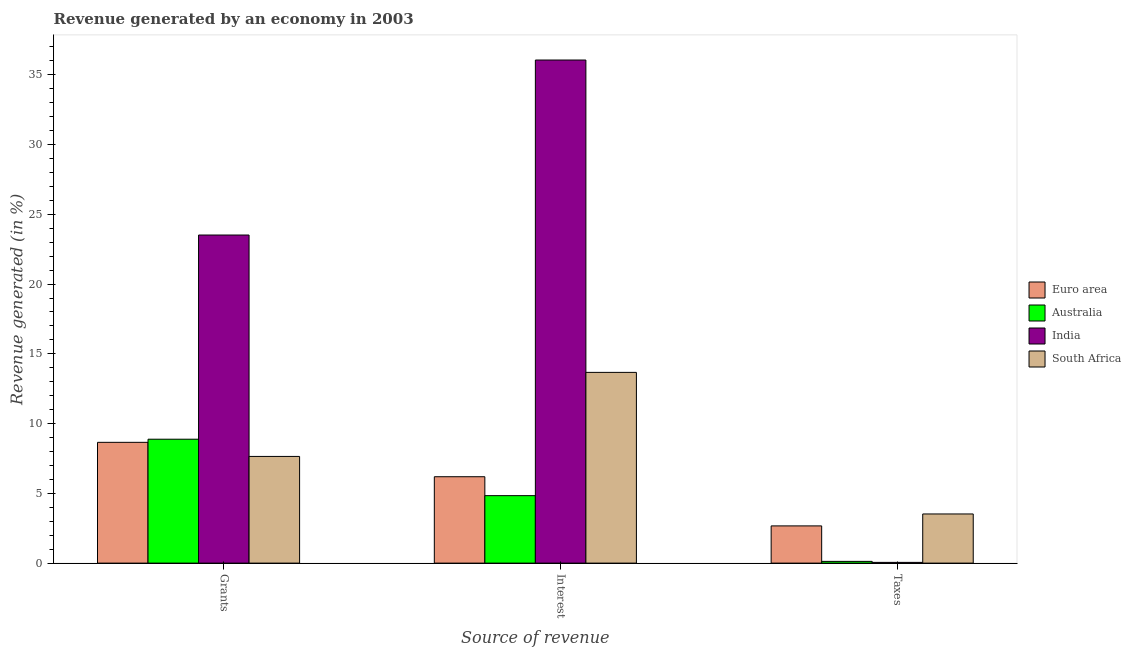How many bars are there on the 1st tick from the left?
Your response must be concise. 4. How many bars are there on the 2nd tick from the right?
Offer a very short reply. 4. What is the label of the 1st group of bars from the left?
Ensure brevity in your answer.  Grants. What is the percentage of revenue generated by grants in Australia?
Provide a short and direct response. 8.88. Across all countries, what is the maximum percentage of revenue generated by grants?
Offer a very short reply. 23.52. Across all countries, what is the minimum percentage of revenue generated by grants?
Give a very brief answer. 7.65. In which country was the percentage of revenue generated by taxes maximum?
Give a very brief answer. South Africa. What is the total percentage of revenue generated by interest in the graph?
Offer a very short reply. 60.76. What is the difference between the percentage of revenue generated by grants in India and that in South Africa?
Give a very brief answer. 15.87. What is the difference between the percentage of revenue generated by grants in Euro area and the percentage of revenue generated by taxes in South Africa?
Offer a very short reply. 5.13. What is the average percentage of revenue generated by interest per country?
Offer a terse response. 15.19. What is the difference between the percentage of revenue generated by grants and percentage of revenue generated by taxes in India?
Keep it short and to the point. 23.46. What is the ratio of the percentage of revenue generated by grants in Australia to that in Euro area?
Offer a very short reply. 1.03. Is the percentage of revenue generated by interest in Euro area less than that in Australia?
Your answer should be compact. No. Is the difference between the percentage of revenue generated by interest in Euro area and India greater than the difference between the percentage of revenue generated by grants in Euro area and India?
Give a very brief answer. No. What is the difference between the highest and the second highest percentage of revenue generated by grants?
Offer a terse response. 14.63. What is the difference between the highest and the lowest percentage of revenue generated by grants?
Your response must be concise. 15.87. In how many countries, is the percentage of revenue generated by grants greater than the average percentage of revenue generated by grants taken over all countries?
Give a very brief answer. 1. Is the sum of the percentage of revenue generated by taxes in South Africa and Euro area greater than the maximum percentage of revenue generated by interest across all countries?
Your response must be concise. No. What does the 4th bar from the left in Taxes represents?
Your answer should be compact. South Africa. What does the 1st bar from the right in Interest represents?
Offer a terse response. South Africa. Is it the case that in every country, the sum of the percentage of revenue generated by grants and percentage of revenue generated by interest is greater than the percentage of revenue generated by taxes?
Offer a terse response. Yes. Does the graph contain grids?
Your answer should be compact. No. Where does the legend appear in the graph?
Give a very brief answer. Center right. How many legend labels are there?
Offer a terse response. 4. How are the legend labels stacked?
Provide a short and direct response. Vertical. What is the title of the graph?
Give a very brief answer. Revenue generated by an economy in 2003. Does "Uruguay" appear as one of the legend labels in the graph?
Keep it short and to the point. No. What is the label or title of the X-axis?
Offer a very short reply. Source of revenue. What is the label or title of the Y-axis?
Provide a succinct answer. Revenue generated (in %). What is the Revenue generated (in %) in Euro area in Grants?
Your response must be concise. 8.66. What is the Revenue generated (in %) of Australia in Grants?
Give a very brief answer. 8.88. What is the Revenue generated (in %) in India in Grants?
Provide a succinct answer. 23.52. What is the Revenue generated (in %) of South Africa in Grants?
Your response must be concise. 7.65. What is the Revenue generated (in %) in Euro area in Interest?
Keep it short and to the point. 6.19. What is the Revenue generated (in %) of Australia in Interest?
Provide a short and direct response. 4.84. What is the Revenue generated (in %) of India in Interest?
Ensure brevity in your answer.  36.06. What is the Revenue generated (in %) of South Africa in Interest?
Keep it short and to the point. 13.67. What is the Revenue generated (in %) in Euro area in Taxes?
Make the answer very short. 2.67. What is the Revenue generated (in %) of Australia in Taxes?
Give a very brief answer. 0.12. What is the Revenue generated (in %) in India in Taxes?
Offer a very short reply. 0.05. What is the Revenue generated (in %) in South Africa in Taxes?
Offer a very short reply. 3.52. Across all Source of revenue, what is the maximum Revenue generated (in %) in Euro area?
Your answer should be compact. 8.66. Across all Source of revenue, what is the maximum Revenue generated (in %) of Australia?
Provide a short and direct response. 8.88. Across all Source of revenue, what is the maximum Revenue generated (in %) of India?
Your response must be concise. 36.06. Across all Source of revenue, what is the maximum Revenue generated (in %) in South Africa?
Give a very brief answer. 13.67. Across all Source of revenue, what is the minimum Revenue generated (in %) in Euro area?
Provide a succinct answer. 2.67. Across all Source of revenue, what is the minimum Revenue generated (in %) of Australia?
Your answer should be compact. 0.12. Across all Source of revenue, what is the minimum Revenue generated (in %) of India?
Offer a very short reply. 0.05. Across all Source of revenue, what is the minimum Revenue generated (in %) of South Africa?
Ensure brevity in your answer.  3.52. What is the total Revenue generated (in %) of Euro area in the graph?
Offer a terse response. 17.52. What is the total Revenue generated (in %) in Australia in the graph?
Make the answer very short. 13.84. What is the total Revenue generated (in %) in India in the graph?
Provide a succinct answer. 59.63. What is the total Revenue generated (in %) of South Africa in the graph?
Offer a terse response. 24.84. What is the difference between the Revenue generated (in %) in Euro area in Grants and that in Interest?
Give a very brief answer. 2.46. What is the difference between the Revenue generated (in %) of Australia in Grants and that in Interest?
Provide a succinct answer. 4.05. What is the difference between the Revenue generated (in %) of India in Grants and that in Interest?
Provide a short and direct response. -12.54. What is the difference between the Revenue generated (in %) of South Africa in Grants and that in Interest?
Provide a short and direct response. -6.03. What is the difference between the Revenue generated (in %) in Euro area in Grants and that in Taxes?
Ensure brevity in your answer.  5.99. What is the difference between the Revenue generated (in %) of Australia in Grants and that in Taxes?
Give a very brief answer. 8.76. What is the difference between the Revenue generated (in %) in India in Grants and that in Taxes?
Offer a very short reply. 23.46. What is the difference between the Revenue generated (in %) in South Africa in Grants and that in Taxes?
Keep it short and to the point. 4.12. What is the difference between the Revenue generated (in %) of Euro area in Interest and that in Taxes?
Give a very brief answer. 3.52. What is the difference between the Revenue generated (in %) of Australia in Interest and that in Taxes?
Provide a short and direct response. 4.71. What is the difference between the Revenue generated (in %) of India in Interest and that in Taxes?
Provide a succinct answer. 36.01. What is the difference between the Revenue generated (in %) of South Africa in Interest and that in Taxes?
Provide a succinct answer. 10.15. What is the difference between the Revenue generated (in %) of Euro area in Grants and the Revenue generated (in %) of Australia in Interest?
Your response must be concise. 3.82. What is the difference between the Revenue generated (in %) of Euro area in Grants and the Revenue generated (in %) of India in Interest?
Make the answer very short. -27.4. What is the difference between the Revenue generated (in %) in Euro area in Grants and the Revenue generated (in %) in South Africa in Interest?
Give a very brief answer. -5.01. What is the difference between the Revenue generated (in %) of Australia in Grants and the Revenue generated (in %) of India in Interest?
Provide a succinct answer. -27.18. What is the difference between the Revenue generated (in %) of Australia in Grants and the Revenue generated (in %) of South Africa in Interest?
Provide a short and direct response. -4.79. What is the difference between the Revenue generated (in %) of India in Grants and the Revenue generated (in %) of South Africa in Interest?
Provide a short and direct response. 9.84. What is the difference between the Revenue generated (in %) in Euro area in Grants and the Revenue generated (in %) in Australia in Taxes?
Your response must be concise. 8.53. What is the difference between the Revenue generated (in %) of Euro area in Grants and the Revenue generated (in %) of India in Taxes?
Your answer should be very brief. 8.6. What is the difference between the Revenue generated (in %) of Euro area in Grants and the Revenue generated (in %) of South Africa in Taxes?
Your response must be concise. 5.13. What is the difference between the Revenue generated (in %) of Australia in Grants and the Revenue generated (in %) of India in Taxes?
Offer a very short reply. 8.83. What is the difference between the Revenue generated (in %) in Australia in Grants and the Revenue generated (in %) in South Africa in Taxes?
Your answer should be very brief. 5.36. What is the difference between the Revenue generated (in %) in India in Grants and the Revenue generated (in %) in South Africa in Taxes?
Your answer should be very brief. 19.99. What is the difference between the Revenue generated (in %) in Euro area in Interest and the Revenue generated (in %) in Australia in Taxes?
Make the answer very short. 6.07. What is the difference between the Revenue generated (in %) in Euro area in Interest and the Revenue generated (in %) in India in Taxes?
Give a very brief answer. 6.14. What is the difference between the Revenue generated (in %) in Euro area in Interest and the Revenue generated (in %) in South Africa in Taxes?
Your answer should be compact. 2.67. What is the difference between the Revenue generated (in %) of Australia in Interest and the Revenue generated (in %) of India in Taxes?
Ensure brevity in your answer.  4.78. What is the difference between the Revenue generated (in %) in Australia in Interest and the Revenue generated (in %) in South Africa in Taxes?
Keep it short and to the point. 1.31. What is the difference between the Revenue generated (in %) of India in Interest and the Revenue generated (in %) of South Africa in Taxes?
Offer a very short reply. 32.54. What is the average Revenue generated (in %) in Euro area per Source of revenue?
Provide a short and direct response. 5.84. What is the average Revenue generated (in %) in Australia per Source of revenue?
Provide a succinct answer. 4.61. What is the average Revenue generated (in %) of India per Source of revenue?
Your answer should be compact. 19.88. What is the average Revenue generated (in %) of South Africa per Source of revenue?
Offer a terse response. 8.28. What is the difference between the Revenue generated (in %) in Euro area and Revenue generated (in %) in Australia in Grants?
Provide a succinct answer. -0.22. What is the difference between the Revenue generated (in %) in Euro area and Revenue generated (in %) in India in Grants?
Make the answer very short. -14.86. What is the difference between the Revenue generated (in %) of Euro area and Revenue generated (in %) of South Africa in Grants?
Provide a succinct answer. 1.01. What is the difference between the Revenue generated (in %) in Australia and Revenue generated (in %) in India in Grants?
Give a very brief answer. -14.63. What is the difference between the Revenue generated (in %) in Australia and Revenue generated (in %) in South Africa in Grants?
Your response must be concise. 1.23. What is the difference between the Revenue generated (in %) in India and Revenue generated (in %) in South Africa in Grants?
Your response must be concise. 15.87. What is the difference between the Revenue generated (in %) of Euro area and Revenue generated (in %) of Australia in Interest?
Give a very brief answer. 1.36. What is the difference between the Revenue generated (in %) in Euro area and Revenue generated (in %) in India in Interest?
Ensure brevity in your answer.  -29.87. What is the difference between the Revenue generated (in %) in Euro area and Revenue generated (in %) in South Africa in Interest?
Your answer should be very brief. -7.48. What is the difference between the Revenue generated (in %) of Australia and Revenue generated (in %) of India in Interest?
Provide a short and direct response. -31.22. What is the difference between the Revenue generated (in %) of Australia and Revenue generated (in %) of South Africa in Interest?
Give a very brief answer. -8.84. What is the difference between the Revenue generated (in %) in India and Revenue generated (in %) in South Africa in Interest?
Offer a terse response. 22.39. What is the difference between the Revenue generated (in %) of Euro area and Revenue generated (in %) of Australia in Taxes?
Give a very brief answer. 2.54. What is the difference between the Revenue generated (in %) of Euro area and Revenue generated (in %) of India in Taxes?
Give a very brief answer. 2.61. What is the difference between the Revenue generated (in %) of Euro area and Revenue generated (in %) of South Africa in Taxes?
Give a very brief answer. -0.86. What is the difference between the Revenue generated (in %) in Australia and Revenue generated (in %) in India in Taxes?
Ensure brevity in your answer.  0.07. What is the difference between the Revenue generated (in %) of Australia and Revenue generated (in %) of South Africa in Taxes?
Your response must be concise. -3.4. What is the difference between the Revenue generated (in %) in India and Revenue generated (in %) in South Africa in Taxes?
Make the answer very short. -3.47. What is the ratio of the Revenue generated (in %) in Euro area in Grants to that in Interest?
Keep it short and to the point. 1.4. What is the ratio of the Revenue generated (in %) of Australia in Grants to that in Interest?
Provide a succinct answer. 1.84. What is the ratio of the Revenue generated (in %) in India in Grants to that in Interest?
Make the answer very short. 0.65. What is the ratio of the Revenue generated (in %) of South Africa in Grants to that in Interest?
Your response must be concise. 0.56. What is the ratio of the Revenue generated (in %) of Euro area in Grants to that in Taxes?
Make the answer very short. 3.25. What is the ratio of the Revenue generated (in %) of Australia in Grants to that in Taxes?
Provide a short and direct response. 71.39. What is the ratio of the Revenue generated (in %) of India in Grants to that in Taxes?
Provide a short and direct response. 445.15. What is the ratio of the Revenue generated (in %) in South Africa in Grants to that in Taxes?
Ensure brevity in your answer.  2.17. What is the ratio of the Revenue generated (in %) in Euro area in Interest to that in Taxes?
Give a very brief answer. 2.32. What is the ratio of the Revenue generated (in %) of Australia in Interest to that in Taxes?
Make the answer very short. 38.87. What is the ratio of the Revenue generated (in %) of India in Interest to that in Taxes?
Your answer should be very brief. 682.57. What is the ratio of the Revenue generated (in %) of South Africa in Interest to that in Taxes?
Give a very brief answer. 3.88. What is the difference between the highest and the second highest Revenue generated (in %) in Euro area?
Ensure brevity in your answer.  2.46. What is the difference between the highest and the second highest Revenue generated (in %) of Australia?
Provide a succinct answer. 4.05. What is the difference between the highest and the second highest Revenue generated (in %) in India?
Your answer should be very brief. 12.54. What is the difference between the highest and the second highest Revenue generated (in %) in South Africa?
Provide a succinct answer. 6.03. What is the difference between the highest and the lowest Revenue generated (in %) of Euro area?
Offer a very short reply. 5.99. What is the difference between the highest and the lowest Revenue generated (in %) of Australia?
Make the answer very short. 8.76. What is the difference between the highest and the lowest Revenue generated (in %) in India?
Your response must be concise. 36.01. What is the difference between the highest and the lowest Revenue generated (in %) of South Africa?
Keep it short and to the point. 10.15. 